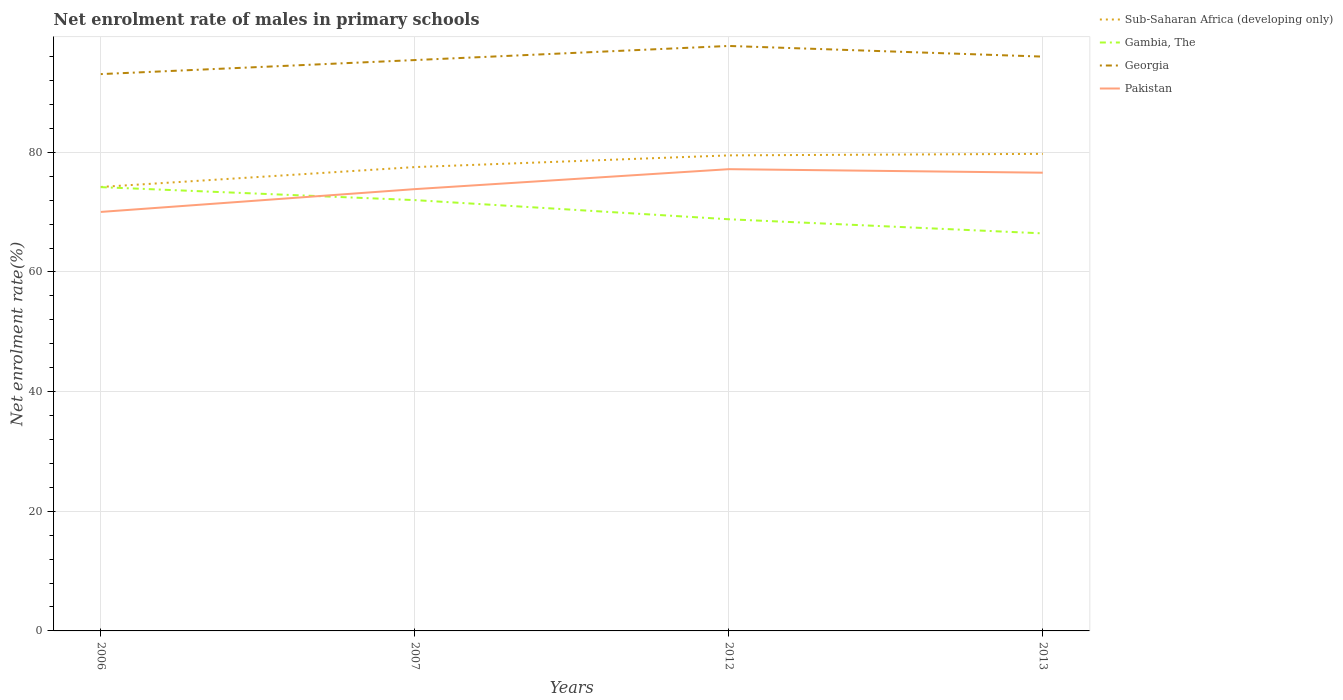Does the line corresponding to Pakistan intersect with the line corresponding to Sub-Saharan Africa (developing only)?
Your response must be concise. No. Is the number of lines equal to the number of legend labels?
Your response must be concise. Yes. Across all years, what is the maximum net enrolment rate of males in primary schools in Gambia, The?
Offer a very short reply. 66.45. In which year was the net enrolment rate of males in primary schools in Gambia, The maximum?
Your response must be concise. 2013. What is the total net enrolment rate of males in primary schools in Gambia, The in the graph?
Provide a short and direct response. 5.56. What is the difference between the highest and the second highest net enrolment rate of males in primary schools in Georgia?
Your answer should be very brief. 4.71. What is the difference between the highest and the lowest net enrolment rate of males in primary schools in Pakistan?
Keep it short and to the point. 2. How many lines are there?
Your answer should be compact. 4. Are the values on the major ticks of Y-axis written in scientific E-notation?
Provide a succinct answer. No. Does the graph contain any zero values?
Your response must be concise. No. Does the graph contain grids?
Your response must be concise. Yes. Where does the legend appear in the graph?
Ensure brevity in your answer.  Top right. What is the title of the graph?
Offer a very short reply. Net enrolment rate of males in primary schools. Does "Fragile and conflict affected situations" appear as one of the legend labels in the graph?
Offer a terse response. No. What is the label or title of the X-axis?
Keep it short and to the point. Years. What is the label or title of the Y-axis?
Your answer should be compact. Net enrolment rate(%). What is the Net enrolment rate(%) of Sub-Saharan Africa (developing only) in 2006?
Your response must be concise. 74.21. What is the Net enrolment rate(%) of Gambia, The in 2006?
Your response must be concise. 74.18. What is the Net enrolment rate(%) of Georgia in 2006?
Offer a very short reply. 93.08. What is the Net enrolment rate(%) in Pakistan in 2006?
Make the answer very short. 70.04. What is the Net enrolment rate(%) in Sub-Saharan Africa (developing only) in 2007?
Make the answer very short. 77.54. What is the Net enrolment rate(%) of Gambia, The in 2007?
Give a very brief answer. 72.02. What is the Net enrolment rate(%) of Georgia in 2007?
Keep it short and to the point. 95.43. What is the Net enrolment rate(%) in Pakistan in 2007?
Make the answer very short. 73.85. What is the Net enrolment rate(%) of Sub-Saharan Africa (developing only) in 2012?
Ensure brevity in your answer.  79.49. What is the Net enrolment rate(%) in Gambia, The in 2012?
Provide a short and direct response. 68.81. What is the Net enrolment rate(%) of Georgia in 2012?
Give a very brief answer. 97.79. What is the Net enrolment rate(%) in Pakistan in 2012?
Provide a succinct answer. 77.19. What is the Net enrolment rate(%) in Sub-Saharan Africa (developing only) in 2013?
Provide a succinct answer. 79.75. What is the Net enrolment rate(%) in Gambia, The in 2013?
Your answer should be compact. 66.45. What is the Net enrolment rate(%) in Georgia in 2013?
Your answer should be compact. 96. What is the Net enrolment rate(%) of Pakistan in 2013?
Make the answer very short. 76.6. Across all years, what is the maximum Net enrolment rate(%) in Sub-Saharan Africa (developing only)?
Give a very brief answer. 79.75. Across all years, what is the maximum Net enrolment rate(%) of Gambia, The?
Provide a succinct answer. 74.18. Across all years, what is the maximum Net enrolment rate(%) of Georgia?
Keep it short and to the point. 97.79. Across all years, what is the maximum Net enrolment rate(%) of Pakistan?
Make the answer very short. 77.19. Across all years, what is the minimum Net enrolment rate(%) of Sub-Saharan Africa (developing only)?
Give a very brief answer. 74.21. Across all years, what is the minimum Net enrolment rate(%) of Gambia, The?
Offer a very short reply. 66.45. Across all years, what is the minimum Net enrolment rate(%) in Georgia?
Ensure brevity in your answer.  93.08. Across all years, what is the minimum Net enrolment rate(%) of Pakistan?
Provide a succinct answer. 70.04. What is the total Net enrolment rate(%) in Sub-Saharan Africa (developing only) in the graph?
Give a very brief answer. 311. What is the total Net enrolment rate(%) in Gambia, The in the graph?
Provide a short and direct response. 281.47. What is the total Net enrolment rate(%) in Georgia in the graph?
Your response must be concise. 382.3. What is the total Net enrolment rate(%) of Pakistan in the graph?
Give a very brief answer. 297.68. What is the difference between the Net enrolment rate(%) in Sub-Saharan Africa (developing only) in 2006 and that in 2007?
Keep it short and to the point. -3.32. What is the difference between the Net enrolment rate(%) in Gambia, The in 2006 and that in 2007?
Provide a short and direct response. 2.17. What is the difference between the Net enrolment rate(%) of Georgia in 2006 and that in 2007?
Give a very brief answer. -2.35. What is the difference between the Net enrolment rate(%) of Pakistan in 2006 and that in 2007?
Ensure brevity in your answer.  -3.81. What is the difference between the Net enrolment rate(%) of Sub-Saharan Africa (developing only) in 2006 and that in 2012?
Provide a succinct answer. -5.28. What is the difference between the Net enrolment rate(%) of Gambia, The in 2006 and that in 2012?
Offer a very short reply. 5.37. What is the difference between the Net enrolment rate(%) in Georgia in 2006 and that in 2012?
Ensure brevity in your answer.  -4.71. What is the difference between the Net enrolment rate(%) of Pakistan in 2006 and that in 2012?
Provide a short and direct response. -7.15. What is the difference between the Net enrolment rate(%) in Sub-Saharan Africa (developing only) in 2006 and that in 2013?
Keep it short and to the point. -5.53. What is the difference between the Net enrolment rate(%) of Gambia, The in 2006 and that in 2013?
Your response must be concise. 7.73. What is the difference between the Net enrolment rate(%) of Georgia in 2006 and that in 2013?
Provide a succinct answer. -2.92. What is the difference between the Net enrolment rate(%) of Pakistan in 2006 and that in 2013?
Your response must be concise. -6.56. What is the difference between the Net enrolment rate(%) in Sub-Saharan Africa (developing only) in 2007 and that in 2012?
Your answer should be very brief. -1.96. What is the difference between the Net enrolment rate(%) in Gambia, The in 2007 and that in 2012?
Offer a terse response. 3.2. What is the difference between the Net enrolment rate(%) of Georgia in 2007 and that in 2012?
Your response must be concise. -2.36. What is the difference between the Net enrolment rate(%) in Pakistan in 2007 and that in 2012?
Provide a short and direct response. -3.34. What is the difference between the Net enrolment rate(%) in Sub-Saharan Africa (developing only) in 2007 and that in 2013?
Make the answer very short. -2.21. What is the difference between the Net enrolment rate(%) in Gambia, The in 2007 and that in 2013?
Your response must be concise. 5.56. What is the difference between the Net enrolment rate(%) in Georgia in 2007 and that in 2013?
Keep it short and to the point. -0.58. What is the difference between the Net enrolment rate(%) in Pakistan in 2007 and that in 2013?
Provide a succinct answer. -2.75. What is the difference between the Net enrolment rate(%) in Sub-Saharan Africa (developing only) in 2012 and that in 2013?
Give a very brief answer. -0.25. What is the difference between the Net enrolment rate(%) of Gambia, The in 2012 and that in 2013?
Make the answer very short. 2.36. What is the difference between the Net enrolment rate(%) in Georgia in 2012 and that in 2013?
Give a very brief answer. 1.78. What is the difference between the Net enrolment rate(%) in Pakistan in 2012 and that in 2013?
Ensure brevity in your answer.  0.59. What is the difference between the Net enrolment rate(%) in Sub-Saharan Africa (developing only) in 2006 and the Net enrolment rate(%) in Gambia, The in 2007?
Provide a succinct answer. 2.2. What is the difference between the Net enrolment rate(%) in Sub-Saharan Africa (developing only) in 2006 and the Net enrolment rate(%) in Georgia in 2007?
Your answer should be compact. -21.21. What is the difference between the Net enrolment rate(%) of Sub-Saharan Africa (developing only) in 2006 and the Net enrolment rate(%) of Pakistan in 2007?
Keep it short and to the point. 0.36. What is the difference between the Net enrolment rate(%) of Gambia, The in 2006 and the Net enrolment rate(%) of Georgia in 2007?
Keep it short and to the point. -21.24. What is the difference between the Net enrolment rate(%) of Gambia, The in 2006 and the Net enrolment rate(%) of Pakistan in 2007?
Offer a terse response. 0.33. What is the difference between the Net enrolment rate(%) in Georgia in 2006 and the Net enrolment rate(%) in Pakistan in 2007?
Offer a very short reply. 19.23. What is the difference between the Net enrolment rate(%) of Sub-Saharan Africa (developing only) in 2006 and the Net enrolment rate(%) of Gambia, The in 2012?
Keep it short and to the point. 5.4. What is the difference between the Net enrolment rate(%) in Sub-Saharan Africa (developing only) in 2006 and the Net enrolment rate(%) in Georgia in 2012?
Make the answer very short. -23.57. What is the difference between the Net enrolment rate(%) in Sub-Saharan Africa (developing only) in 2006 and the Net enrolment rate(%) in Pakistan in 2012?
Offer a very short reply. -2.97. What is the difference between the Net enrolment rate(%) in Gambia, The in 2006 and the Net enrolment rate(%) in Georgia in 2012?
Provide a succinct answer. -23.6. What is the difference between the Net enrolment rate(%) of Gambia, The in 2006 and the Net enrolment rate(%) of Pakistan in 2012?
Offer a terse response. -3. What is the difference between the Net enrolment rate(%) in Georgia in 2006 and the Net enrolment rate(%) in Pakistan in 2012?
Provide a succinct answer. 15.89. What is the difference between the Net enrolment rate(%) in Sub-Saharan Africa (developing only) in 2006 and the Net enrolment rate(%) in Gambia, The in 2013?
Your answer should be compact. 7.76. What is the difference between the Net enrolment rate(%) in Sub-Saharan Africa (developing only) in 2006 and the Net enrolment rate(%) in Georgia in 2013?
Make the answer very short. -21.79. What is the difference between the Net enrolment rate(%) of Sub-Saharan Africa (developing only) in 2006 and the Net enrolment rate(%) of Pakistan in 2013?
Provide a short and direct response. -2.39. What is the difference between the Net enrolment rate(%) in Gambia, The in 2006 and the Net enrolment rate(%) in Georgia in 2013?
Give a very brief answer. -21.82. What is the difference between the Net enrolment rate(%) of Gambia, The in 2006 and the Net enrolment rate(%) of Pakistan in 2013?
Keep it short and to the point. -2.42. What is the difference between the Net enrolment rate(%) of Georgia in 2006 and the Net enrolment rate(%) of Pakistan in 2013?
Offer a terse response. 16.48. What is the difference between the Net enrolment rate(%) of Sub-Saharan Africa (developing only) in 2007 and the Net enrolment rate(%) of Gambia, The in 2012?
Provide a short and direct response. 8.72. What is the difference between the Net enrolment rate(%) of Sub-Saharan Africa (developing only) in 2007 and the Net enrolment rate(%) of Georgia in 2012?
Keep it short and to the point. -20.25. What is the difference between the Net enrolment rate(%) in Sub-Saharan Africa (developing only) in 2007 and the Net enrolment rate(%) in Pakistan in 2012?
Keep it short and to the point. 0.35. What is the difference between the Net enrolment rate(%) in Gambia, The in 2007 and the Net enrolment rate(%) in Georgia in 2012?
Ensure brevity in your answer.  -25.77. What is the difference between the Net enrolment rate(%) in Gambia, The in 2007 and the Net enrolment rate(%) in Pakistan in 2012?
Give a very brief answer. -5.17. What is the difference between the Net enrolment rate(%) in Georgia in 2007 and the Net enrolment rate(%) in Pakistan in 2012?
Offer a terse response. 18.24. What is the difference between the Net enrolment rate(%) of Sub-Saharan Africa (developing only) in 2007 and the Net enrolment rate(%) of Gambia, The in 2013?
Provide a succinct answer. 11.08. What is the difference between the Net enrolment rate(%) in Sub-Saharan Africa (developing only) in 2007 and the Net enrolment rate(%) in Georgia in 2013?
Offer a very short reply. -18.47. What is the difference between the Net enrolment rate(%) of Sub-Saharan Africa (developing only) in 2007 and the Net enrolment rate(%) of Pakistan in 2013?
Your response must be concise. 0.94. What is the difference between the Net enrolment rate(%) of Gambia, The in 2007 and the Net enrolment rate(%) of Georgia in 2013?
Provide a short and direct response. -23.99. What is the difference between the Net enrolment rate(%) of Gambia, The in 2007 and the Net enrolment rate(%) of Pakistan in 2013?
Your answer should be very brief. -4.58. What is the difference between the Net enrolment rate(%) of Georgia in 2007 and the Net enrolment rate(%) of Pakistan in 2013?
Your answer should be very brief. 18.83. What is the difference between the Net enrolment rate(%) in Sub-Saharan Africa (developing only) in 2012 and the Net enrolment rate(%) in Gambia, The in 2013?
Provide a succinct answer. 13.04. What is the difference between the Net enrolment rate(%) in Sub-Saharan Africa (developing only) in 2012 and the Net enrolment rate(%) in Georgia in 2013?
Ensure brevity in your answer.  -16.51. What is the difference between the Net enrolment rate(%) in Sub-Saharan Africa (developing only) in 2012 and the Net enrolment rate(%) in Pakistan in 2013?
Give a very brief answer. 2.89. What is the difference between the Net enrolment rate(%) in Gambia, The in 2012 and the Net enrolment rate(%) in Georgia in 2013?
Make the answer very short. -27.19. What is the difference between the Net enrolment rate(%) in Gambia, The in 2012 and the Net enrolment rate(%) in Pakistan in 2013?
Your answer should be very brief. -7.79. What is the difference between the Net enrolment rate(%) in Georgia in 2012 and the Net enrolment rate(%) in Pakistan in 2013?
Your response must be concise. 21.19. What is the average Net enrolment rate(%) in Sub-Saharan Africa (developing only) per year?
Provide a short and direct response. 77.75. What is the average Net enrolment rate(%) of Gambia, The per year?
Give a very brief answer. 70.37. What is the average Net enrolment rate(%) of Georgia per year?
Ensure brevity in your answer.  95.58. What is the average Net enrolment rate(%) in Pakistan per year?
Your response must be concise. 74.42. In the year 2006, what is the difference between the Net enrolment rate(%) in Sub-Saharan Africa (developing only) and Net enrolment rate(%) in Gambia, The?
Your response must be concise. 0.03. In the year 2006, what is the difference between the Net enrolment rate(%) in Sub-Saharan Africa (developing only) and Net enrolment rate(%) in Georgia?
Provide a short and direct response. -18.87. In the year 2006, what is the difference between the Net enrolment rate(%) of Sub-Saharan Africa (developing only) and Net enrolment rate(%) of Pakistan?
Your response must be concise. 4.17. In the year 2006, what is the difference between the Net enrolment rate(%) in Gambia, The and Net enrolment rate(%) in Georgia?
Make the answer very short. -18.9. In the year 2006, what is the difference between the Net enrolment rate(%) in Gambia, The and Net enrolment rate(%) in Pakistan?
Provide a succinct answer. 4.14. In the year 2006, what is the difference between the Net enrolment rate(%) in Georgia and Net enrolment rate(%) in Pakistan?
Your answer should be very brief. 23.04. In the year 2007, what is the difference between the Net enrolment rate(%) in Sub-Saharan Africa (developing only) and Net enrolment rate(%) in Gambia, The?
Your answer should be compact. 5.52. In the year 2007, what is the difference between the Net enrolment rate(%) in Sub-Saharan Africa (developing only) and Net enrolment rate(%) in Georgia?
Keep it short and to the point. -17.89. In the year 2007, what is the difference between the Net enrolment rate(%) in Sub-Saharan Africa (developing only) and Net enrolment rate(%) in Pakistan?
Ensure brevity in your answer.  3.69. In the year 2007, what is the difference between the Net enrolment rate(%) of Gambia, The and Net enrolment rate(%) of Georgia?
Give a very brief answer. -23.41. In the year 2007, what is the difference between the Net enrolment rate(%) of Gambia, The and Net enrolment rate(%) of Pakistan?
Provide a succinct answer. -1.83. In the year 2007, what is the difference between the Net enrolment rate(%) in Georgia and Net enrolment rate(%) in Pakistan?
Your answer should be very brief. 21.58. In the year 2012, what is the difference between the Net enrolment rate(%) in Sub-Saharan Africa (developing only) and Net enrolment rate(%) in Gambia, The?
Your response must be concise. 10.68. In the year 2012, what is the difference between the Net enrolment rate(%) in Sub-Saharan Africa (developing only) and Net enrolment rate(%) in Georgia?
Your answer should be very brief. -18.29. In the year 2012, what is the difference between the Net enrolment rate(%) of Sub-Saharan Africa (developing only) and Net enrolment rate(%) of Pakistan?
Your response must be concise. 2.31. In the year 2012, what is the difference between the Net enrolment rate(%) in Gambia, The and Net enrolment rate(%) in Georgia?
Make the answer very short. -28.97. In the year 2012, what is the difference between the Net enrolment rate(%) in Gambia, The and Net enrolment rate(%) in Pakistan?
Your response must be concise. -8.37. In the year 2012, what is the difference between the Net enrolment rate(%) in Georgia and Net enrolment rate(%) in Pakistan?
Offer a very short reply. 20.6. In the year 2013, what is the difference between the Net enrolment rate(%) of Sub-Saharan Africa (developing only) and Net enrolment rate(%) of Gambia, The?
Offer a very short reply. 13.3. In the year 2013, what is the difference between the Net enrolment rate(%) in Sub-Saharan Africa (developing only) and Net enrolment rate(%) in Georgia?
Offer a terse response. -16.26. In the year 2013, what is the difference between the Net enrolment rate(%) of Sub-Saharan Africa (developing only) and Net enrolment rate(%) of Pakistan?
Offer a terse response. 3.15. In the year 2013, what is the difference between the Net enrolment rate(%) in Gambia, The and Net enrolment rate(%) in Georgia?
Provide a succinct answer. -29.55. In the year 2013, what is the difference between the Net enrolment rate(%) in Gambia, The and Net enrolment rate(%) in Pakistan?
Your answer should be very brief. -10.15. In the year 2013, what is the difference between the Net enrolment rate(%) of Georgia and Net enrolment rate(%) of Pakistan?
Make the answer very short. 19.4. What is the ratio of the Net enrolment rate(%) in Sub-Saharan Africa (developing only) in 2006 to that in 2007?
Provide a short and direct response. 0.96. What is the ratio of the Net enrolment rate(%) of Gambia, The in 2006 to that in 2007?
Make the answer very short. 1.03. What is the ratio of the Net enrolment rate(%) in Georgia in 2006 to that in 2007?
Your answer should be compact. 0.98. What is the ratio of the Net enrolment rate(%) in Pakistan in 2006 to that in 2007?
Provide a succinct answer. 0.95. What is the ratio of the Net enrolment rate(%) in Sub-Saharan Africa (developing only) in 2006 to that in 2012?
Ensure brevity in your answer.  0.93. What is the ratio of the Net enrolment rate(%) of Gambia, The in 2006 to that in 2012?
Provide a succinct answer. 1.08. What is the ratio of the Net enrolment rate(%) of Georgia in 2006 to that in 2012?
Make the answer very short. 0.95. What is the ratio of the Net enrolment rate(%) in Pakistan in 2006 to that in 2012?
Your answer should be compact. 0.91. What is the ratio of the Net enrolment rate(%) in Sub-Saharan Africa (developing only) in 2006 to that in 2013?
Your answer should be very brief. 0.93. What is the ratio of the Net enrolment rate(%) in Gambia, The in 2006 to that in 2013?
Your answer should be very brief. 1.12. What is the ratio of the Net enrolment rate(%) in Georgia in 2006 to that in 2013?
Make the answer very short. 0.97. What is the ratio of the Net enrolment rate(%) in Pakistan in 2006 to that in 2013?
Keep it short and to the point. 0.91. What is the ratio of the Net enrolment rate(%) in Sub-Saharan Africa (developing only) in 2007 to that in 2012?
Offer a very short reply. 0.98. What is the ratio of the Net enrolment rate(%) in Gambia, The in 2007 to that in 2012?
Offer a very short reply. 1.05. What is the ratio of the Net enrolment rate(%) of Georgia in 2007 to that in 2012?
Your response must be concise. 0.98. What is the ratio of the Net enrolment rate(%) in Pakistan in 2007 to that in 2012?
Your answer should be compact. 0.96. What is the ratio of the Net enrolment rate(%) of Sub-Saharan Africa (developing only) in 2007 to that in 2013?
Provide a succinct answer. 0.97. What is the ratio of the Net enrolment rate(%) in Gambia, The in 2007 to that in 2013?
Your answer should be very brief. 1.08. What is the ratio of the Net enrolment rate(%) of Georgia in 2007 to that in 2013?
Provide a succinct answer. 0.99. What is the ratio of the Net enrolment rate(%) of Pakistan in 2007 to that in 2013?
Your answer should be very brief. 0.96. What is the ratio of the Net enrolment rate(%) in Sub-Saharan Africa (developing only) in 2012 to that in 2013?
Offer a terse response. 1. What is the ratio of the Net enrolment rate(%) of Gambia, The in 2012 to that in 2013?
Make the answer very short. 1.04. What is the ratio of the Net enrolment rate(%) in Georgia in 2012 to that in 2013?
Your response must be concise. 1.02. What is the ratio of the Net enrolment rate(%) in Pakistan in 2012 to that in 2013?
Offer a terse response. 1.01. What is the difference between the highest and the second highest Net enrolment rate(%) in Sub-Saharan Africa (developing only)?
Give a very brief answer. 0.25. What is the difference between the highest and the second highest Net enrolment rate(%) of Gambia, The?
Keep it short and to the point. 2.17. What is the difference between the highest and the second highest Net enrolment rate(%) in Georgia?
Offer a terse response. 1.78. What is the difference between the highest and the second highest Net enrolment rate(%) in Pakistan?
Give a very brief answer. 0.59. What is the difference between the highest and the lowest Net enrolment rate(%) of Sub-Saharan Africa (developing only)?
Provide a succinct answer. 5.53. What is the difference between the highest and the lowest Net enrolment rate(%) of Gambia, The?
Offer a terse response. 7.73. What is the difference between the highest and the lowest Net enrolment rate(%) in Georgia?
Your answer should be very brief. 4.71. What is the difference between the highest and the lowest Net enrolment rate(%) in Pakistan?
Offer a terse response. 7.15. 